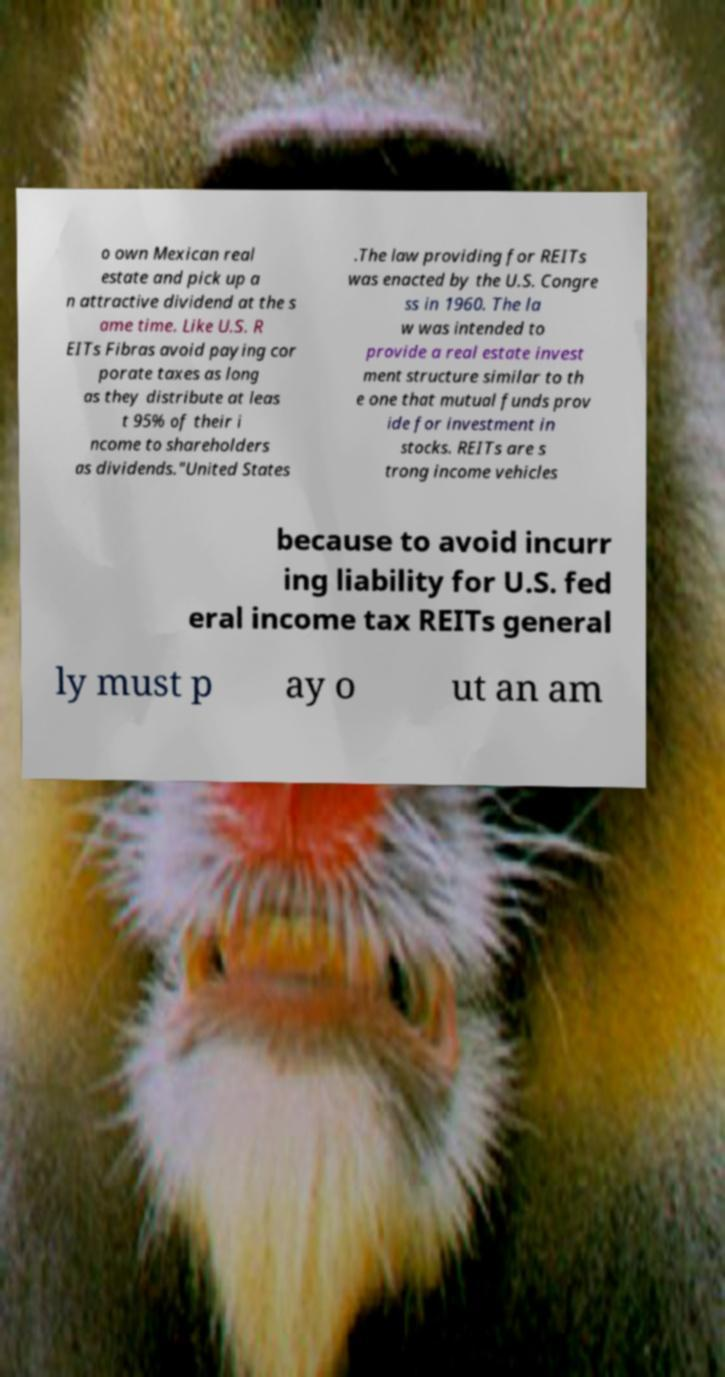Please identify and transcribe the text found in this image. o own Mexican real estate and pick up a n attractive dividend at the s ame time. Like U.S. R EITs Fibras avoid paying cor porate taxes as long as they distribute at leas t 95% of their i ncome to shareholders as dividends."United States .The law providing for REITs was enacted by the U.S. Congre ss in 1960. The la w was intended to provide a real estate invest ment structure similar to th e one that mutual funds prov ide for investment in stocks. REITs are s trong income vehicles because to avoid incurr ing liability for U.S. fed eral income tax REITs general ly must p ay o ut an am 